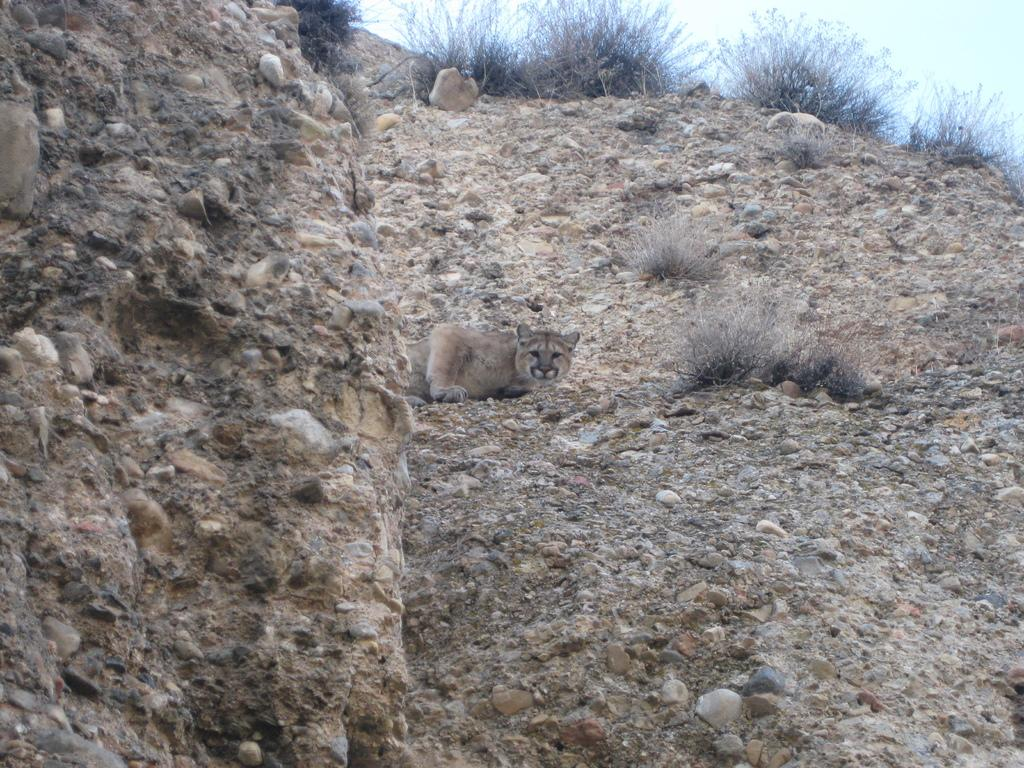What animal is present in the image? There is a leopard in the image. Where is the leopard located in relation to the rock? The leopard is hiding behind a rock. Can you describe the location of the rock? The rock is on a hill. What type of vegetation is present above the leopard? There are dried plants above the leopard. What can be seen in the background of the image? The sky is visible in the background of the image. What is the purpose of the bells in the image? There are no bells present in the image. Can you describe the crow's behavior in the image? There is no crow present in the image. 